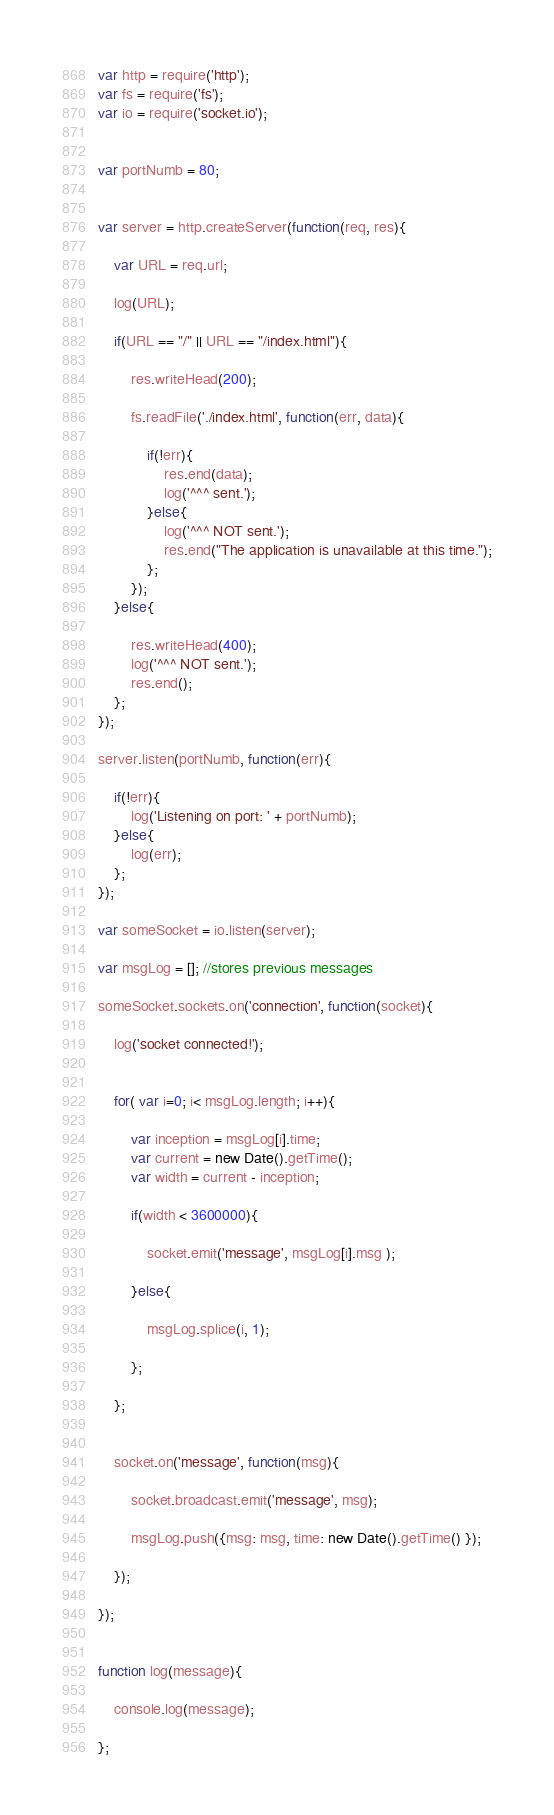<code> <loc_0><loc_0><loc_500><loc_500><_JavaScript_>var http = require('http');
var fs = require('fs');
var io = require('socket.io');


var portNumb = 80;


var server = http.createServer(function(req, res){
    
    var URL = req.url;
    
    log(URL);
    
    if(URL == "/" || URL == "/index.html"){
        
        res.writeHead(200);
        
        fs.readFile('./index.html', function(err, data){

            if(!err){
                res.end(data);
                log('^^^ sent.');
            }else{
                log('^^^ NOT sent.'); 
                res.end("The application is unavailable at this time.");
            };
        });
    }else{
        
        res.writeHead(400);
        log('^^^ NOT sent.');
        res.end();
    };
});

server.listen(portNumb, function(err){
    
    if(!err){
        log('Listening on port: ' + portNumb);
    }else{
        log(err);  
    };
});

var someSocket = io.listen(server);

var msgLog = []; //stores previous messages

someSocket.sockets.on('connection', function(socket){
    
    log('socket connected!');
    
    
    for( var i=0; i< msgLog.length; i++){
        
        var inception = msgLog[i].time;
        var current = new Date().getTime();
        var width = current - inception;
        
        if(width < 3600000){
            
            socket.emit('message', msgLog[i].msg );
            
        }else{
            
            msgLog.splice(i, 1);
            
        };
        
    };
    
    
    socket.on('message', function(msg){
        
        socket.broadcast.emit('message', msg);
        
        msgLog.push({msg: msg, time: new Date().getTime() });
        
    });
    
});


function log(message){
    
    console.log(message);
    
};</code> 